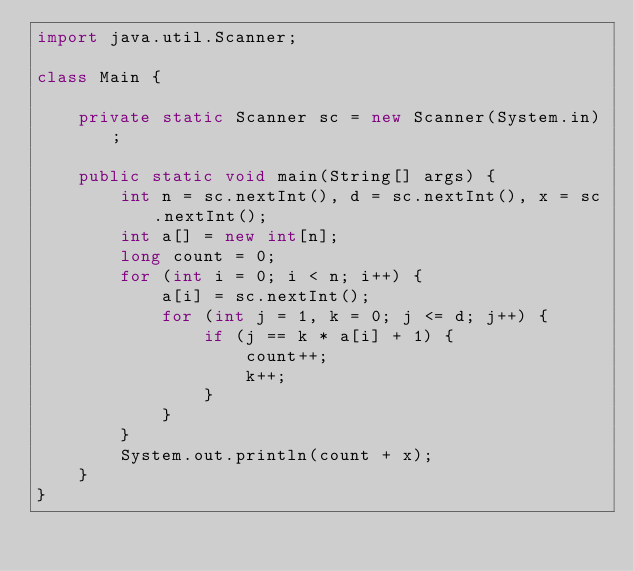<code> <loc_0><loc_0><loc_500><loc_500><_Java_>import java.util.Scanner;

class Main {

    private static Scanner sc = new Scanner(System.in);

    public static void main(String[] args) {
        int n = sc.nextInt(), d = sc.nextInt(), x = sc.nextInt();
        int a[] = new int[n];
        long count = 0;
        for (int i = 0; i < n; i++) {
            a[i] = sc.nextInt();
            for (int j = 1, k = 0; j <= d; j++) {
                if (j == k * a[i] + 1) {
                    count++;
                    k++;
                }
            }
        }
        System.out.println(count + x);
    }
}</code> 